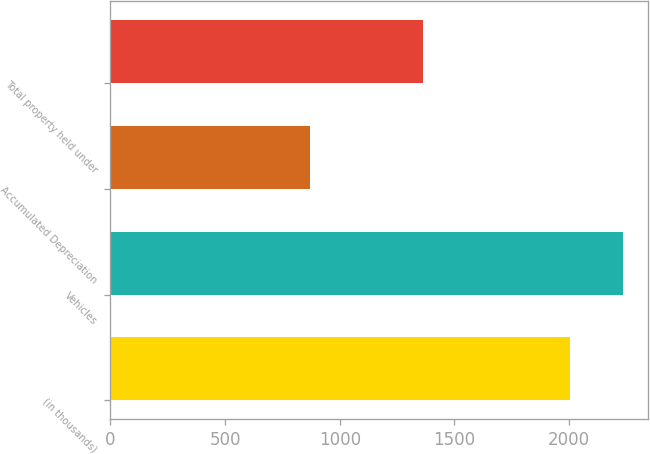<chart> <loc_0><loc_0><loc_500><loc_500><bar_chart><fcel>(in thousands)<fcel>Vehicles<fcel>Accumulated Depreciation<fcel>Total property held under<nl><fcel>2005<fcel>2234<fcel>871<fcel>1363<nl></chart> 